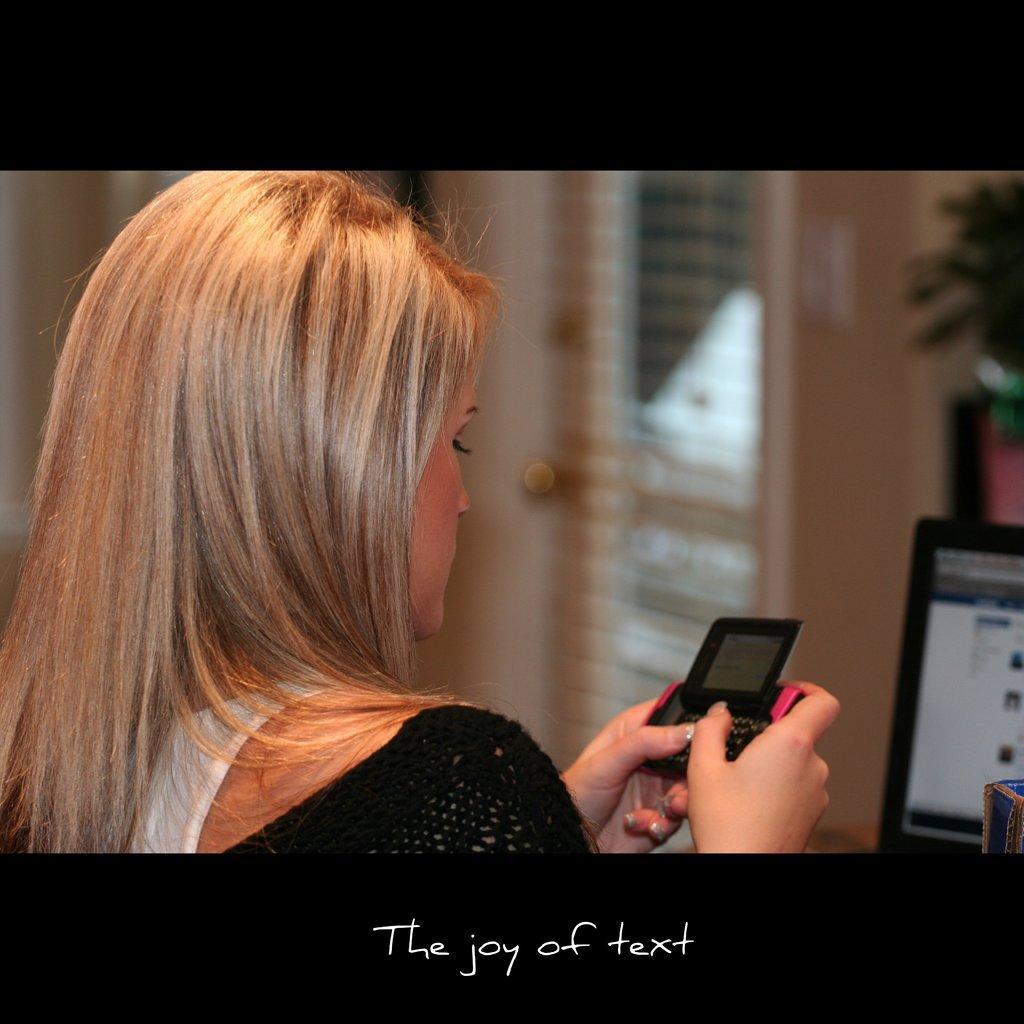In one or two sentences, can you explain what this image depicts? In this image I can see a woman is using the mobile phone, on the right side it looks like a laptop. 